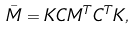<formula> <loc_0><loc_0><loc_500><loc_500>\bar { M } = K C M ^ { T } C ^ { T } K ,</formula> 